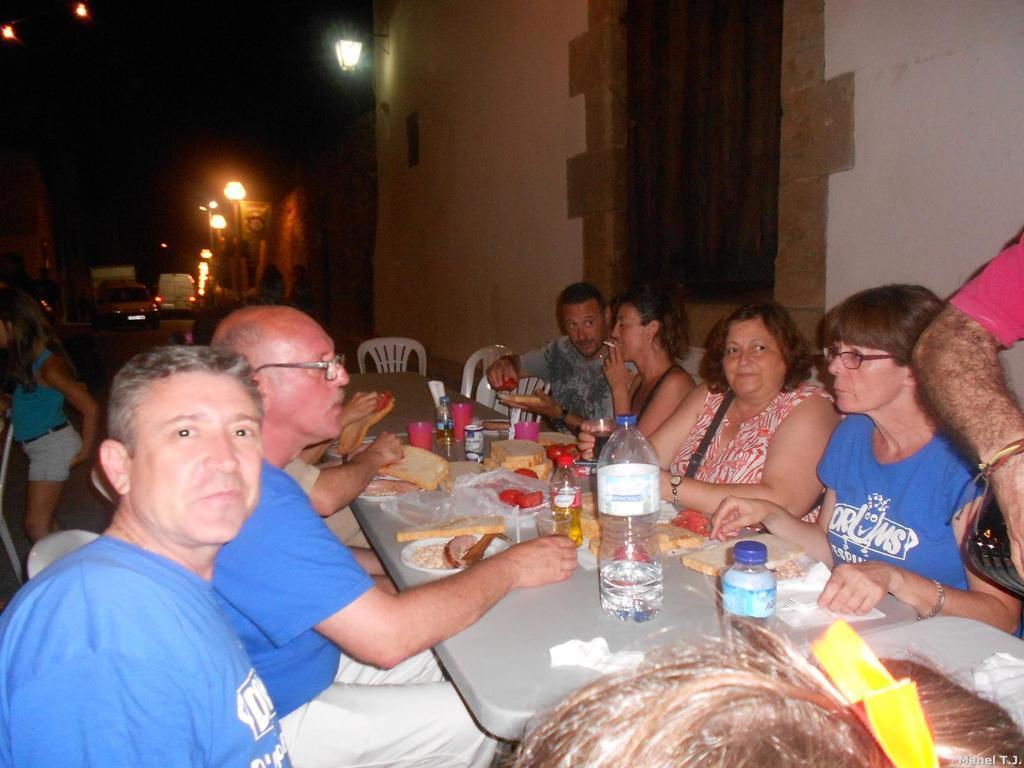Describe this image in one or two sentences. This picture might be taken in a restaurant. In this image, we can see a group of people sitting on the chair in front of the table. On that table, we can see few water bottles, bread, plate, tissues, glass and some food items. On the left side, we can see a woman standing. In the background, we can see a car and a vehicle which is placed on the road, street lights. At the top, we can see black color. 